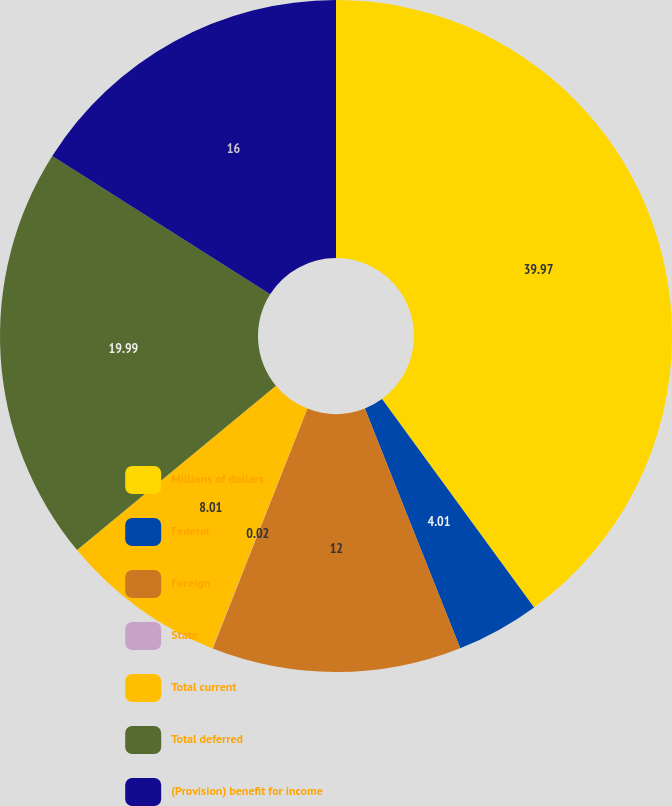Convert chart. <chart><loc_0><loc_0><loc_500><loc_500><pie_chart><fcel>Millions of dollars<fcel>Federal<fcel>Foreign<fcel>State<fcel>Total current<fcel>Total deferred<fcel>(Provision) benefit for income<nl><fcel>39.96%<fcel>4.01%<fcel>12.0%<fcel>0.02%<fcel>8.01%<fcel>19.99%<fcel>16.0%<nl></chart> 